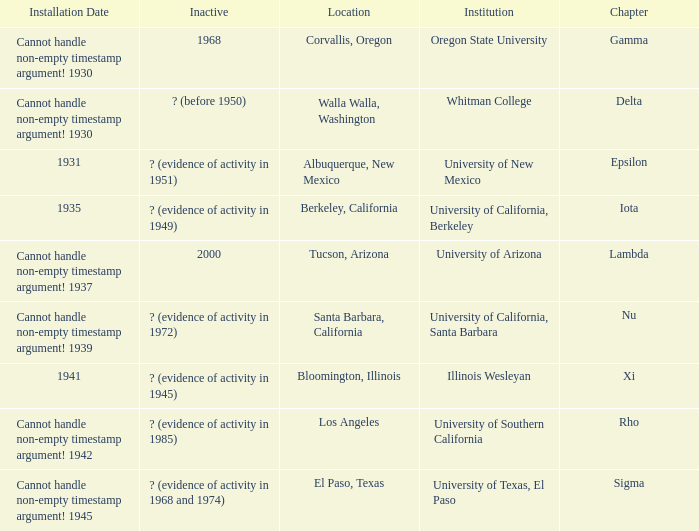What was the installation date in El Paso, Texas?  Cannot handle non-empty timestamp argument! 1945. 